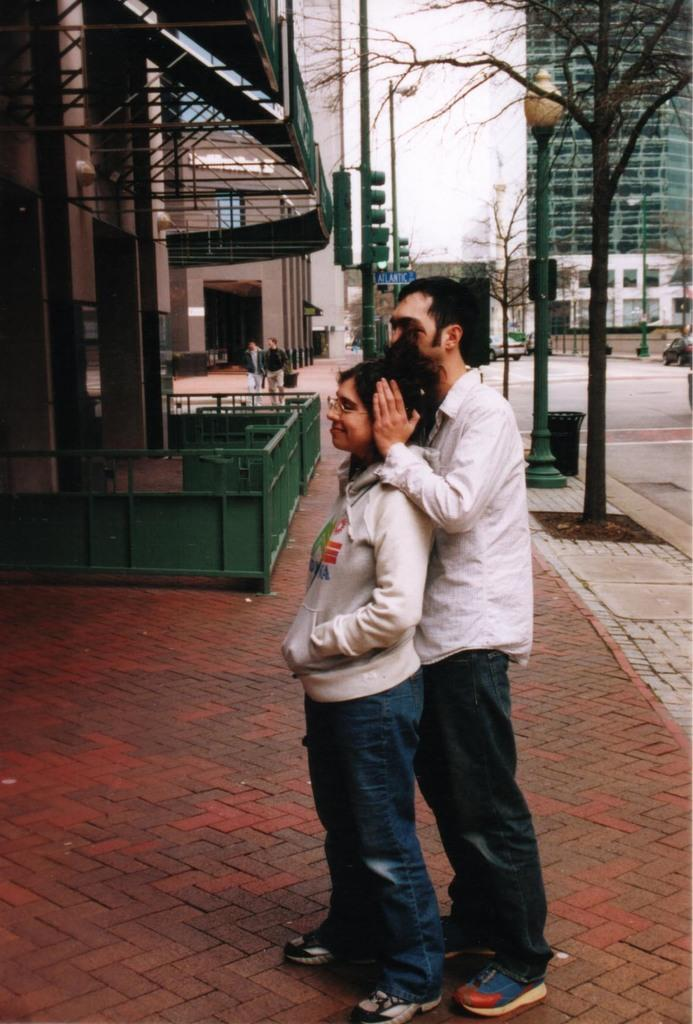How many people are in the image? There are two persons standing in the center of the image. Where are the persons standing? The persons are standing on the pavement. What can be seen in the background of the image? There are buildings and trees in the background of the image. What is the purpose of the street light in the image? The street light is likely for illuminating the area at night. What type of surface can be seen in the image? There is a road in the image. What type of knowledge is the person on the left displaying on their face in the image? There is no indication of any knowledge being displayed on the persons' faces in the image. What time does the watch on the person's wrist show in the image? There is no watch visible on any person's wrist in the image. 